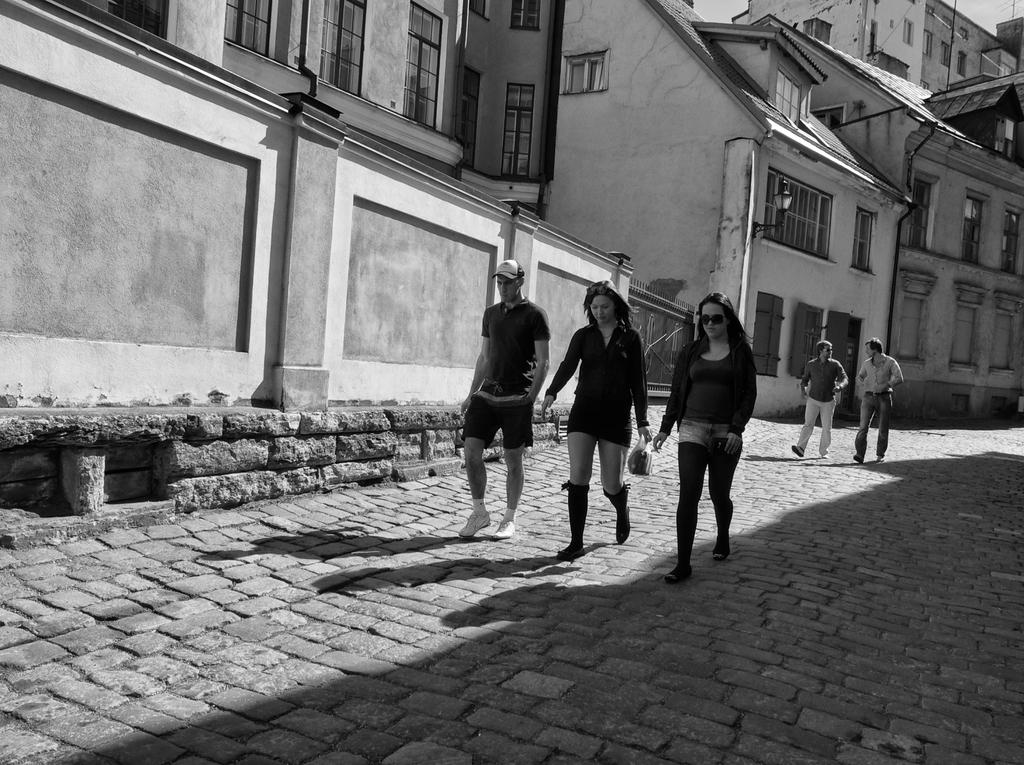What are the people in the image doing? The people in the image are walking. What are the people wearing while walking? The people are wearing clothes and shoes. What type of surface are the people walking on? There is a footpath in the image. What can be seen in the background of the image? There are buildings with visible windows in the image. What type of wool is being used to make the furniture in the image? There is no furniture present in the image, so it is not possible to determine the type of wool being used. 